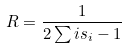<formula> <loc_0><loc_0><loc_500><loc_500>R = \frac { 1 } { 2 \sum i s _ { i } - 1 }</formula> 